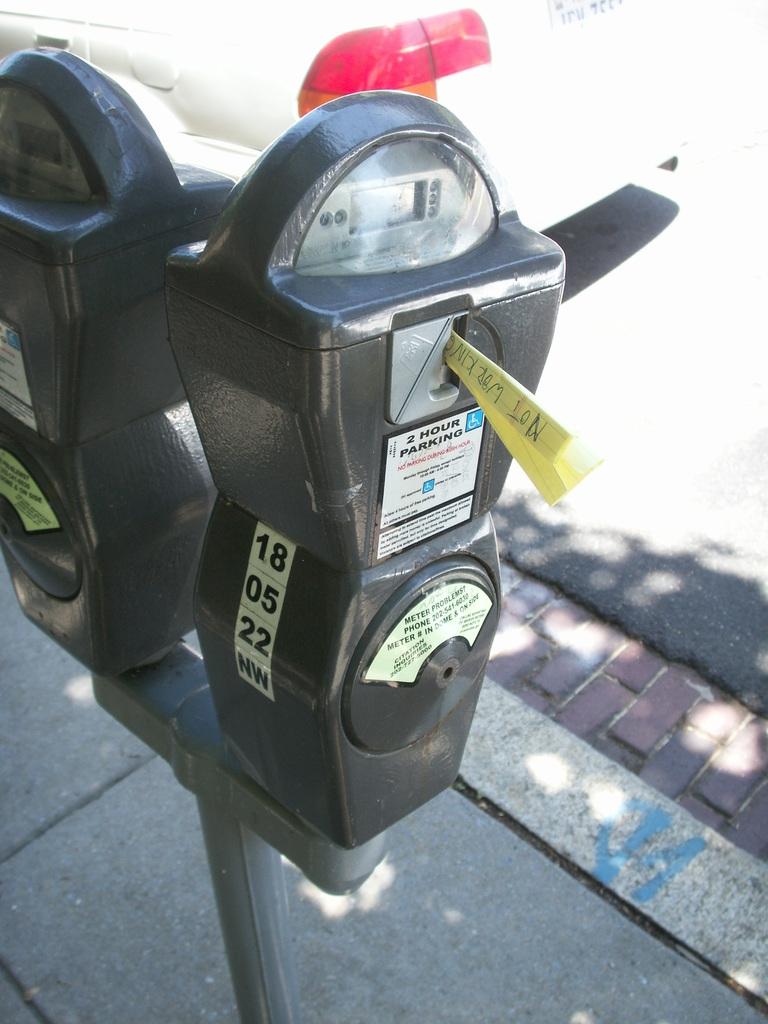What is the meter number?
Keep it short and to the point. 18 05 22. What is the parking limit here?
Make the answer very short. Unanswerable. 